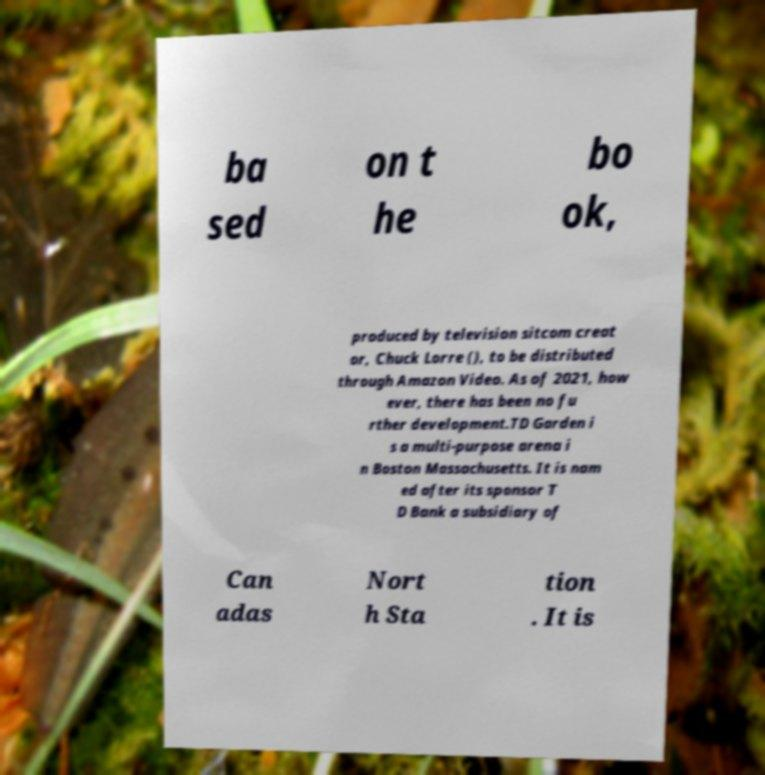For documentation purposes, I need the text within this image transcribed. Could you provide that? ba sed on t he bo ok, produced by television sitcom creat or, Chuck Lorre (), to be distributed through Amazon Video. As of 2021, how ever, there has been no fu rther development.TD Garden i s a multi-purpose arena i n Boston Massachusetts. It is nam ed after its sponsor T D Bank a subsidiary of Can adas Nort h Sta tion . It is 